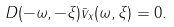<formula> <loc_0><loc_0><loc_500><loc_500>D ( - \omega , - \xi ) \bar { v } _ { x } ( \omega , \xi ) = 0 .</formula> 